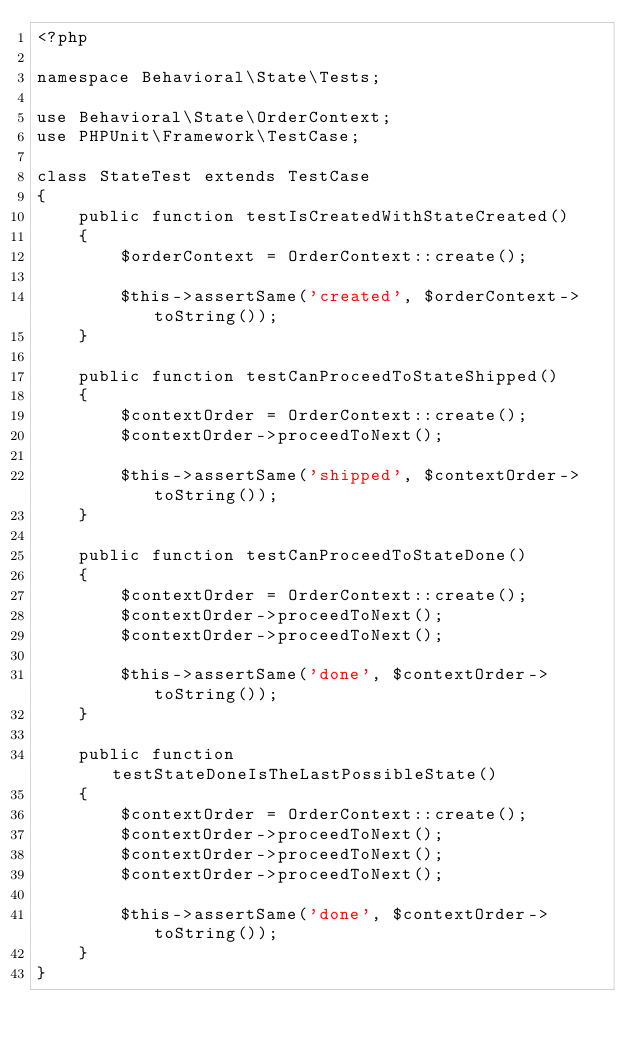Convert code to text. <code><loc_0><loc_0><loc_500><loc_500><_PHP_><?php

namespace Behavioral\State\Tests;

use Behavioral\State\OrderContext;
use PHPUnit\Framework\TestCase;

class StateTest extends TestCase
{
    public function testIsCreatedWithStateCreated()
    {
        $orderContext = OrderContext::create();

        $this->assertSame('created', $orderContext->toString());
    }

    public function testCanProceedToStateShipped()
    {
        $contextOrder = OrderContext::create();
        $contextOrder->proceedToNext();

        $this->assertSame('shipped', $contextOrder->toString());
    }

    public function testCanProceedToStateDone()
    {
        $contextOrder = OrderContext::create();
        $contextOrder->proceedToNext();
        $contextOrder->proceedToNext();

        $this->assertSame('done', $contextOrder->toString());
    }

    public function testStateDoneIsTheLastPossibleState()
    {
        $contextOrder = OrderContext::create();
        $contextOrder->proceedToNext();
        $contextOrder->proceedToNext();
        $contextOrder->proceedToNext();

        $this->assertSame('done', $contextOrder->toString());
    }
}</code> 